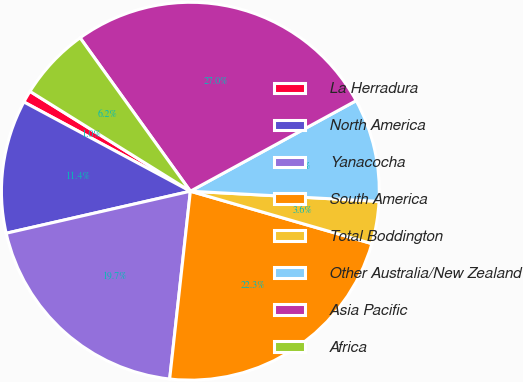Convert chart. <chart><loc_0><loc_0><loc_500><loc_500><pie_chart><fcel>La Herradura<fcel>North America<fcel>Yanacocha<fcel>South America<fcel>Total Boddington<fcel>Other Australia/New Zealand<fcel>Asia Pacific<fcel>Africa<nl><fcel>1.03%<fcel>11.4%<fcel>19.68%<fcel>22.27%<fcel>3.62%<fcel>8.81%<fcel>26.96%<fcel>6.22%<nl></chart> 